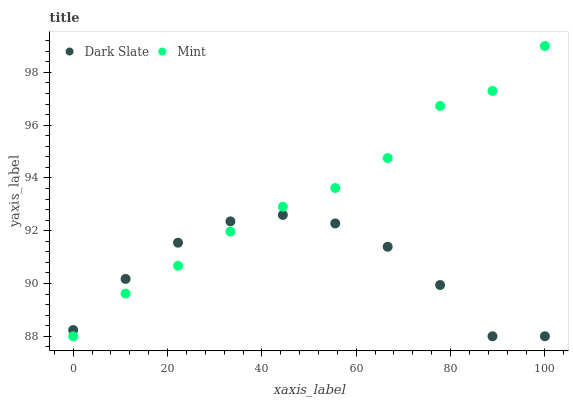Does Dark Slate have the minimum area under the curve?
Answer yes or no. Yes. Does Mint have the maximum area under the curve?
Answer yes or no. Yes. Does Mint have the minimum area under the curve?
Answer yes or no. No. Is Mint the smoothest?
Answer yes or no. Yes. Is Dark Slate the roughest?
Answer yes or no. Yes. Is Mint the roughest?
Answer yes or no. No. Does Dark Slate have the lowest value?
Answer yes or no. Yes. Does Mint have the highest value?
Answer yes or no. Yes. Does Mint intersect Dark Slate?
Answer yes or no. Yes. Is Mint less than Dark Slate?
Answer yes or no. No. Is Mint greater than Dark Slate?
Answer yes or no. No. 